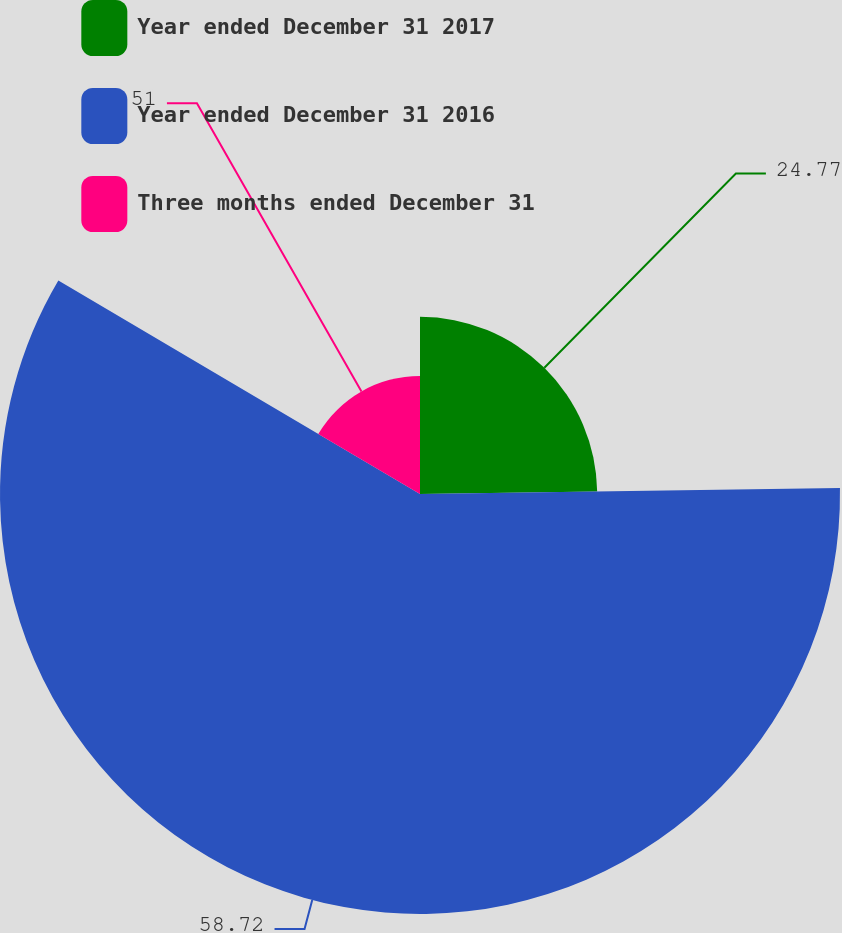Convert chart. <chart><loc_0><loc_0><loc_500><loc_500><pie_chart><fcel>Year ended December 31 2017<fcel>Year ended December 31 2016<fcel>Three months ended December 31<nl><fcel>24.77%<fcel>58.72%<fcel>16.51%<nl></chart> 